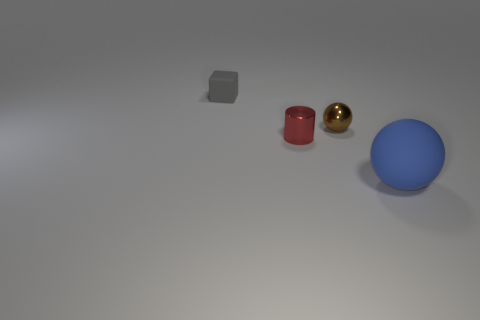What textures do the objects appear to have? The objects in the image have distinct textures. The gray cube seems to have a matte surface, the brown cylinder looks reflective, the gold object has a shiny, possibly metallic finish, and the blue sphere appears to have a smooth, matte surface. 